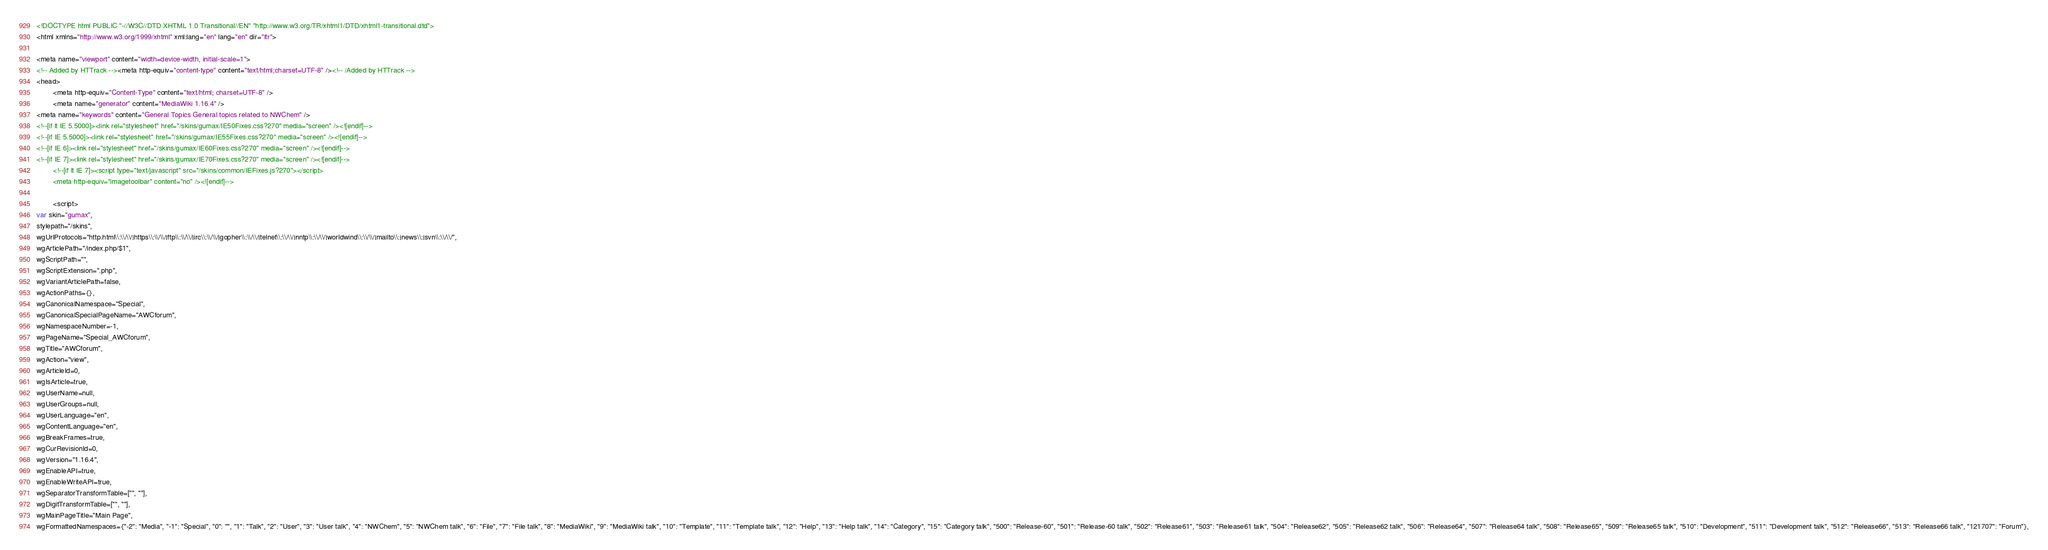Convert code to text. <code><loc_0><loc_0><loc_500><loc_500><_HTML_><!DOCTYPE html PUBLIC "-//W3C//DTD XHTML 1.0 Transitional//EN" "http://www.w3.org/TR/xhtml1/DTD/xhtml1-transitional.dtd">
<html xmlns="http://www.w3.org/1999/xhtml" xml:lang="en" lang="en" dir="ltr">
	
<meta name="viewport" content="width=device-width, initial-scale=1">
<!-- Added by HTTrack --><meta http-equiv="content-type" content="text/html;charset=UTF-8" /><!-- /Added by HTTrack -->
<head>
		<meta http-equiv="Content-Type" content="text/html; charset=UTF-8" />
		<meta name="generator" content="MediaWiki 1.16.4" />
<meta name="keywords" content="General Topics General topics related to NWChem" />
<!--[if lt IE 5.5000]><link rel="stylesheet" href="/skins/gumax/IE50Fixes.css?270" media="screen" /><![endif]-->
<!--[if IE 5.5000]><link rel="stylesheet" href="/skins/gumax/IE55Fixes.css?270" media="screen" /><![endif]-->
<!--[if IE 6]><link rel="stylesheet" href="/skins/gumax/IE60Fixes.css?270" media="screen" /><![endif]-->
<!--[if IE 7]><link rel="stylesheet" href="/skins/gumax/IE70Fixes.css?270" media="screen" /><![endif]-->
		<!--[if lt IE 7]><script type="text/javascript" src="/skins/common/IEFixes.js?270"></script>
		<meta http-equiv="imagetoolbar" content="no" /><![endif]-->

		<script>
var skin="gumax",
stylepath="/skins",
wgUrlProtocols="http.html\\:\\/\\/|https\\:\\/\\/|ftp\\:\\/\\/|irc\\:\\/\\/|gopher\\:\\/\\/|telnet\\:\\/\\/|nntp\\:\\/\\/|worldwind\\:\\/\\/|mailto\\:|news\\:|svn\\:\\/\\/",
wgArticlePath="/index.php/$1",
wgScriptPath="",
wgScriptExtension=".php",
wgVariantArticlePath=false,
wgActionPaths={},
wgCanonicalNamespace="Special",
wgCanonicalSpecialPageName="AWCforum",
wgNamespaceNumber=-1,
wgPageName="Special_AWCforum",
wgTitle="AWCforum",
wgAction="view",
wgArticleId=0,
wgIsArticle=true,
wgUserName=null,
wgUserGroups=null,
wgUserLanguage="en",
wgContentLanguage="en",
wgBreakFrames=true,
wgCurRevisionId=0,
wgVersion="1.16.4",
wgEnableAPI=true,
wgEnableWriteAPI=true,
wgSeparatorTransformTable=["", ""],
wgDigitTransformTable=["", ""],
wgMainPageTitle="Main Page",
wgFormattedNamespaces={"-2": "Media", "-1": "Special", "0": "", "1": "Talk", "2": "User", "3": "User talk", "4": "NWChem", "5": "NWChem talk", "6": "File", "7": "File talk", "8": "MediaWiki", "9": "MediaWiki talk", "10": "Template", "11": "Template talk", "12": "Help", "13": "Help talk", "14": "Category", "15": "Category talk", "500": "Release-60", "501": "Release-60 talk", "502": "Release61", "503": "Release61 talk", "504": "Release62", "505": "Release62 talk", "506": "Release64", "507": "Release64 talk", "508": "Release65", "509": "Release65 talk", "510": "Development", "511": "Development talk", "512": "Release66", "513": "Release66 talk", "121707": "Forum"},</code> 